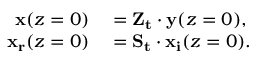<formula> <loc_0><loc_0><loc_500><loc_500>\begin{array} { r l } { x ( z = 0 ) } & = Z _ { t } \cdot y ( z = 0 ) , } \\ { x _ { r } ( z = 0 ) } & = S _ { t } \cdot x _ { i } ( z = 0 ) . } \end{array}</formula> 